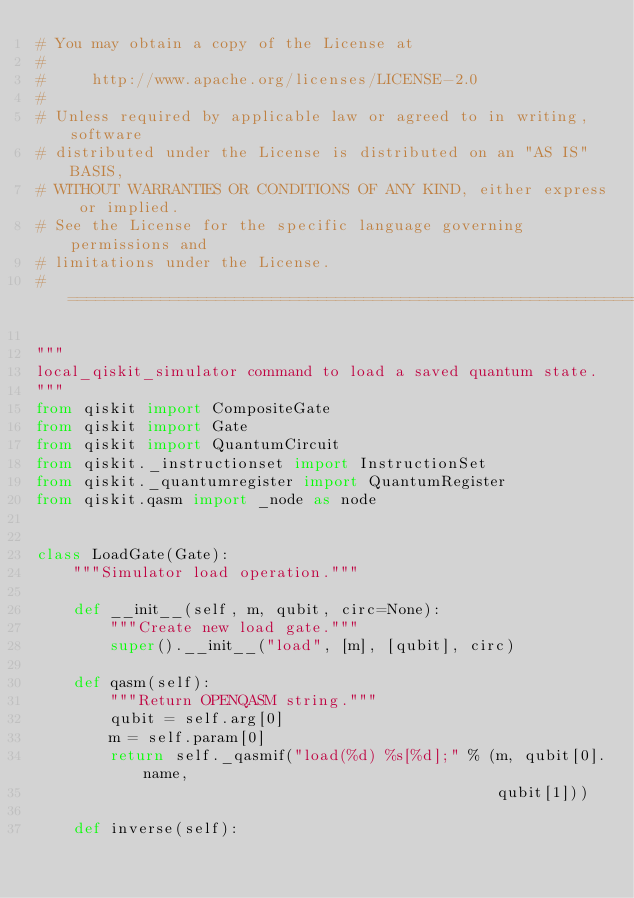Convert code to text. <code><loc_0><loc_0><loc_500><loc_500><_Python_># You may obtain a copy of the License at
#
#     http://www.apache.org/licenses/LICENSE-2.0
#
# Unless required by applicable law or agreed to in writing, software
# distributed under the License is distributed on an "AS IS" BASIS,
# WITHOUT WARRANTIES OR CONDITIONS OF ANY KIND, either express or implied.
# See the License for the specific language governing permissions and
# limitations under the License.
# =============================================================================

"""
local_qiskit_simulator command to load a saved quantum state.
"""
from qiskit import CompositeGate
from qiskit import Gate
from qiskit import QuantumCircuit
from qiskit._instructionset import InstructionSet
from qiskit._quantumregister import QuantumRegister
from qiskit.qasm import _node as node


class LoadGate(Gate):
    """Simulator load operation."""

    def __init__(self, m, qubit, circ=None):
        """Create new load gate."""
        super().__init__("load", [m], [qubit], circ)

    def qasm(self):
        """Return OPENQASM string."""
        qubit = self.arg[0]
        m = self.param[0]
        return self._qasmif("load(%d) %s[%d];" % (m, qubit[0].name,
                                                  qubit[1]))

    def inverse(self):</code> 